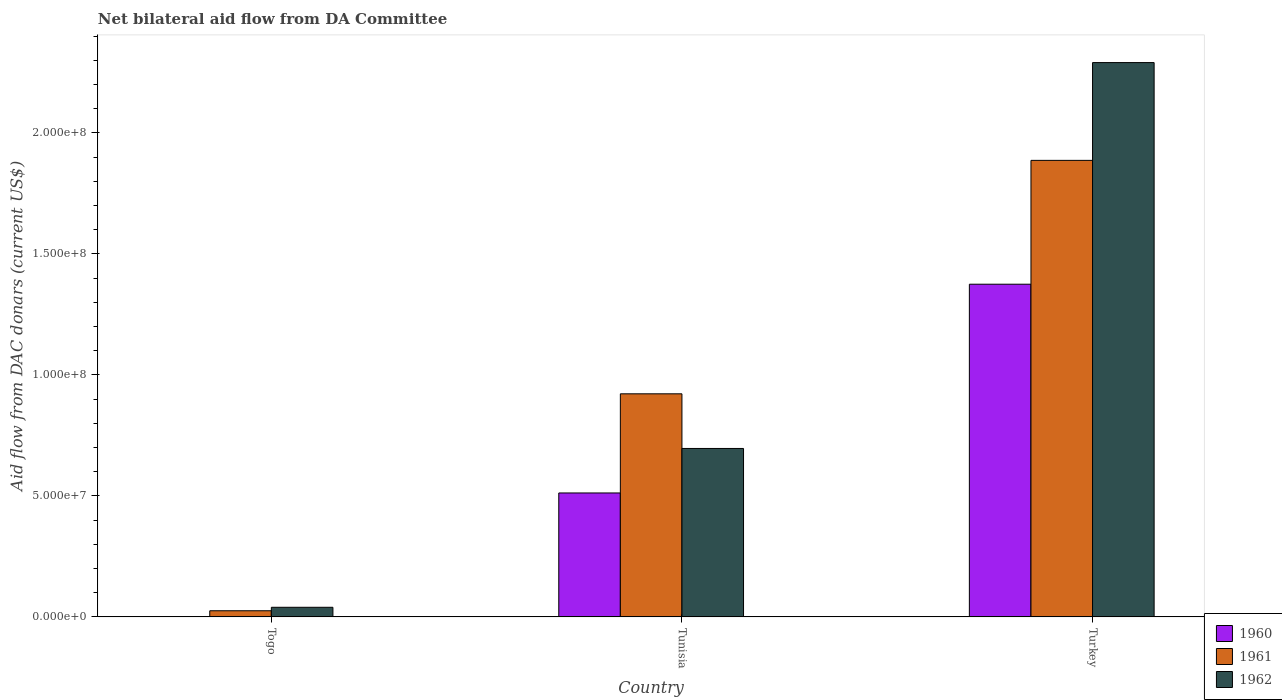How many different coloured bars are there?
Your response must be concise. 3. How many groups of bars are there?
Your answer should be very brief. 3. Are the number of bars per tick equal to the number of legend labels?
Ensure brevity in your answer.  Yes. Are the number of bars on each tick of the X-axis equal?
Keep it short and to the point. Yes. How many bars are there on the 3rd tick from the right?
Your response must be concise. 3. What is the label of the 1st group of bars from the left?
Offer a terse response. Togo. In how many cases, is the number of bars for a given country not equal to the number of legend labels?
Provide a short and direct response. 0. What is the aid flow in in 1960 in Turkey?
Provide a succinct answer. 1.37e+08. Across all countries, what is the maximum aid flow in in 1961?
Make the answer very short. 1.89e+08. Across all countries, what is the minimum aid flow in in 1962?
Your answer should be compact. 3.96e+06. In which country was the aid flow in in 1962 maximum?
Provide a succinct answer. Turkey. In which country was the aid flow in in 1960 minimum?
Ensure brevity in your answer.  Togo. What is the total aid flow in in 1961 in the graph?
Your response must be concise. 2.83e+08. What is the difference between the aid flow in in 1961 in Tunisia and that in Turkey?
Your answer should be compact. -9.65e+07. What is the difference between the aid flow in in 1960 in Togo and the aid flow in in 1962 in Tunisia?
Provide a short and direct response. -6.96e+07. What is the average aid flow in in 1961 per country?
Provide a succinct answer. 9.44e+07. What is the difference between the aid flow in of/in 1961 and aid flow in of/in 1960 in Tunisia?
Provide a short and direct response. 4.10e+07. In how many countries, is the aid flow in in 1961 greater than 20000000 US$?
Your response must be concise. 2. What is the ratio of the aid flow in in 1961 in Tunisia to that in Turkey?
Keep it short and to the point. 0.49. What is the difference between the highest and the second highest aid flow in in 1961?
Ensure brevity in your answer.  9.65e+07. What is the difference between the highest and the lowest aid flow in in 1962?
Ensure brevity in your answer.  2.25e+08. In how many countries, is the aid flow in in 1960 greater than the average aid flow in in 1960 taken over all countries?
Give a very brief answer. 1. Is the sum of the aid flow in in 1962 in Tunisia and Turkey greater than the maximum aid flow in in 1960 across all countries?
Make the answer very short. Yes. What does the 2nd bar from the right in Turkey represents?
Offer a terse response. 1961. Are all the bars in the graph horizontal?
Offer a terse response. No. Are the values on the major ticks of Y-axis written in scientific E-notation?
Offer a terse response. Yes. Does the graph contain grids?
Your response must be concise. No. How are the legend labels stacked?
Offer a terse response. Vertical. What is the title of the graph?
Give a very brief answer. Net bilateral aid flow from DA Committee. What is the label or title of the X-axis?
Provide a short and direct response. Country. What is the label or title of the Y-axis?
Ensure brevity in your answer.  Aid flow from DAC donars (current US$). What is the Aid flow from DAC donars (current US$) of 1961 in Togo?
Your answer should be compact. 2.53e+06. What is the Aid flow from DAC donars (current US$) in 1962 in Togo?
Offer a very short reply. 3.96e+06. What is the Aid flow from DAC donars (current US$) in 1960 in Tunisia?
Provide a succinct answer. 5.12e+07. What is the Aid flow from DAC donars (current US$) in 1961 in Tunisia?
Provide a short and direct response. 9.22e+07. What is the Aid flow from DAC donars (current US$) of 1962 in Tunisia?
Your answer should be very brief. 6.96e+07. What is the Aid flow from DAC donars (current US$) in 1960 in Turkey?
Your answer should be compact. 1.37e+08. What is the Aid flow from DAC donars (current US$) in 1961 in Turkey?
Provide a succinct answer. 1.89e+08. What is the Aid flow from DAC donars (current US$) of 1962 in Turkey?
Offer a terse response. 2.29e+08. Across all countries, what is the maximum Aid flow from DAC donars (current US$) in 1960?
Ensure brevity in your answer.  1.37e+08. Across all countries, what is the maximum Aid flow from DAC donars (current US$) of 1961?
Provide a succinct answer. 1.89e+08. Across all countries, what is the maximum Aid flow from DAC donars (current US$) in 1962?
Provide a short and direct response. 2.29e+08. Across all countries, what is the minimum Aid flow from DAC donars (current US$) of 1960?
Provide a short and direct response. 3.00e+04. Across all countries, what is the minimum Aid flow from DAC donars (current US$) of 1961?
Your answer should be compact. 2.53e+06. Across all countries, what is the minimum Aid flow from DAC donars (current US$) in 1962?
Make the answer very short. 3.96e+06. What is the total Aid flow from DAC donars (current US$) in 1960 in the graph?
Keep it short and to the point. 1.89e+08. What is the total Aid flow from DAC donars (current US$) in 1961 in the graph?
Keep it short and to the point. 2.83e+08. What is the total Aid flow from DAC donars (current US$) of 1962 in the graph?
Make the answer very short. 3.03e+08. What is the difference between the Aid flow from DAC donars (current US$) in 1960 in Togo and that in Tunisia?
Your answer should be very brief. -5.12e+07. What is the difference between the Aid flow from DAC donars (current US$) of 1961 in Togo and that in Tunisia?
Offer a very short reply. -8.96e+07. What is the difference between the Aid flow from DAC donars (current US$) in 1962 in Togo and that in Tunisia?
Make the answer very short. -6.56e+07. What is the difference between the Aid flow from DAC donars (current US$) in 1960 in Togo and that in Turkey?
Keep it short and to the point. -1.37e+08. What is the difference between the Aid flow from DAC donars (current US$) of 1961 in Togo and that in Turkey?
Your answer should be very brief. -1.86e+08. What is the difference between the Aid flow from DAC donars (current US$) of 1962 in Togo and that in Turkey?
Offer a terse response. -2.25e+08. What is the difference between the Aid flow from DAC donars (current US$) of 1960 in Tunisia and that in Turkey?
Make the answer very short. -8.63e+07. What is the difference between the Aid flow from DAC donars (current US$) in 1961 in Tunisia and that in Turkey?
Give a very brief answer. -9.65e+07. What is the difference between the Aid flow from DAC donars (current US$) of 1962 in Tunisia and that in Turkey?
Your response must be concise. -1.59e+08. What is the difference between the Aid flow from DAC donars (current US$) in 1960 in Togo and the Aid flow from DAC donars (current US$) in 1961 in Tunisia?
Your answer should be very brief. -9.21e+07. What is the difference between the Aid flow from DAC donars (current US$) in 1960 in Togo and the Aid flow from DAC donars (current US$) in 1962 in Tunisia?
Provide a short and direct response. -6.96e+07. What is the difference between the Aid flow from DAC donars (current US$) in 1961 in Togo and the Aid flow from DAC donars (current US$) in 1962 in Tunisia?
Offer a very short reply. -6.71e+07. What is the difference between the Aid flow from DAC donars (current US$) in 1960 in Togo and the Aid flow from DAC donars (current US$) in 1961 in Turkey?
Keep it short and to the point. -1.89e+08. What is the difference between the Aid flow from DAC donars (current US$) in 1960 in Togo and the Aid flow from DAC donars (current US$) in 1962 in Turkey?
Ensure brevity in your answer.  -2.29e+08. What is the difference between the Aid flow from DAC donars (current US$) in 1961 in Togo and the Aid flow from DAC donars (current US$) in 1962 in Turkey?
Your answer should be compact. -2.26e+08. What is the difference between the Aid flow from DAC donars (current US$) in 1960 in Tunisia and the Aid flow from DAC donars (current US$) in 1961 in Turkey?
Your answer should be very brief. -1.37e+08. What is the difference between the Aid flow from DAC donars (current US$) in 1960 in Tunisia and the Aid flow from DAC donars (current US$) in 1962 in Turkey?
Your response must be concise. -1.78e+08. What is the difference between the Aid flow from DAC donars (current US$) of 1961 in Tunisia and the Aid flow from DAC donars (current US$) of 1962 in Turkey?
Provide a short and direct response. -1.37e+08. What is the average Aid flow from DAC donars (current US$) of 1960 per country?
Keep it short and to the point. 6.29e+07. What is the average Aid flow from DAC donars (current US$) in 1961 per country?
Ensure brevity in your answer.  9.44e+07. What is the average Aid flow from DAC donars (current US$) of 1962 per country?
Ensure brevity in your answer.  1.01e+08. What is the difference between the Aid flow from DAC donars (current US$) of 1960 and Aid flow from DAC donars (current US$) of 1961 in Togo?
Your response must be concise. -2.50e+06. What is the difference between the Aid flow from DAC donars (current US$) of 1960 and Aid flow from DAC donars (current US$) of 1962 in Togo?
Your answer should be very brief. -3.93e+06. What is the difference between the Aid flow from DAC donars (current US$) in 1961 and Aid flow from DAC donars (current US$) in 1962 in Togo?
Your answer should be compact. -1.43e+06. What is the difference between the Aid flow from DAC donars (current US$) in 1960 and Aid flow from DAC donars (current US$) in 1961 in Tunisia?
Offer a terse response. -4.10e+07. What is the difference between the Aid flow from DAC donars (current US$) in 1960 and Aid flow from DAC donars (current US$) in 1962 in Tunisia?
Your answer should be compact. -1.84e+07. What is the difference between the Aid flow from DAC donars (current US$) in 1961 and Aid flow from DAC donars (current US$) in 1962 in Tunisia?
Make the answer very short. 2.26e+07. What is the difference between the Aid flow from DAC donars (current US$) of 1960 and Aid flow from DAC donars (current US$) of 1961 in Turkey?
Offer a terse response. -5.12e+07. What is the difference between the Aid flow from DAC donars (current US$) of 1960 and Aid flow from DAC donars (current US$) of 1962 in Turkey?
Your answer should be compact. -9.16e+07. What is the difference between the Aid flow from DAC donars (current US$) of 1961 and Aid flow from DAC donars (current US$) of 1962 in Turkey?
Provide a succinct answer. -4.04e+07. What is the ratio of the Aid flow from DAC donars (current US$) in 1960 in Togo to that in Tunisia?
Provide a short and direct response. 0. What is the ratio of the Aid flow from DAC donars (current US$) of 1961 in Togo to that in Tunisia?
Your answer should be compact. 0.03. What is the ratio of the Aid flow from DAC donars (current US$) in 1962 in Togo to that in Tunisia?
Make the answer very short. 0.06. What is the ratio of the Aid flow from DAC donars (current US$) in 1961 in Togo to that in Turkey?
Ensure brevity in your answer.  0.01. What is the ratio of the Aid flow from DAC donars (current US$) in 1962 in Togo to that in Turkey?
Offer a very short reply. 0.02. What is the ratio of the Aid flow from DAC donars (current US$) of 1960 in Tunisia to that in Turkey?
Ensure brevity in your answer.  0.37. What is the ratio of the Aid flow from DAC donars (current US$) in 1961 in Tunisia to that in Turkey?
Your response must be concise. 0.49. What is the ratio of the Aid flow from DAC donars (current US$) of 1962 in Tunisia to that in Turkey?
Offer a very short reply. 0.3. What is the difference between the highest and the second highest Aid flow from DAC donars (current US$) of 1960?
Your answer should be compact. 8.63e+07. What is the difference between the highest and the second highest Aid flow from DAC donars (current US$) of 1961?
Offer a very short reply. 9.65e+07. What is the difference between the highest and the second highest Aid flow from DAC donars (current US$) in 1962?
Keep it short and to the point. 1.59e+08. What is the difference between the highest and the lowest Aid flow from DAC donars (current US$) in 1960?
Provide a short and direct response. 1.37e+08. What is the difference between the highest and the lowest Aid flow from DAC donars (current US$) in 1961?
Provide a succinct answer. 1.86e+08. What is the difference between the highest and the lowest Aid flow from DAC donars (current US$) of 1962?
Ensure brevity in your answer.  2.25e+08. 